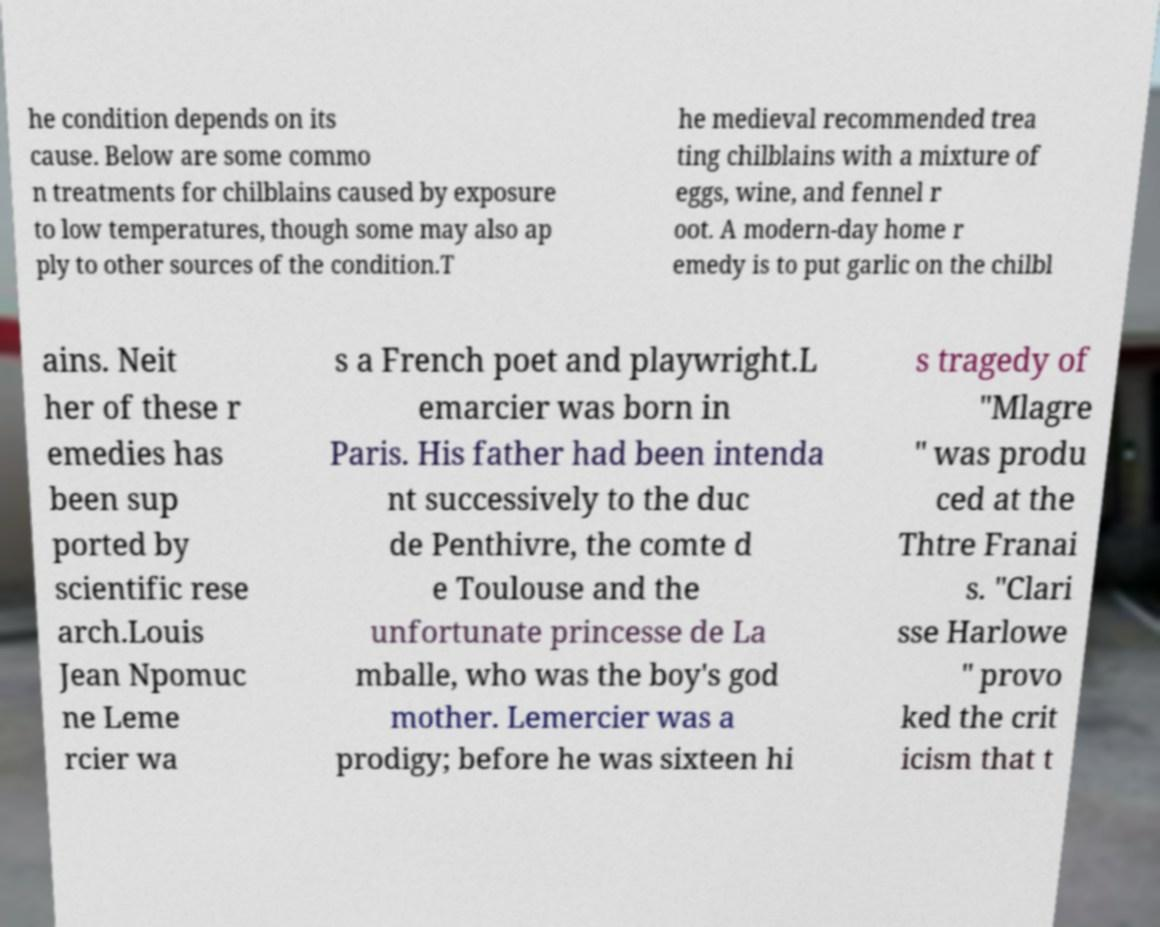Can you read and provide the text displayed in the image?This photo seems to have some interesting text. Can you extract and type it out for me? he condition depends on its cause. Below are some commo n treatments for chilblains caused by exposure to low temperatures, though some may also ap ply to other sources of the condition.T he medieval recommended trea ting chilblains with a mixture of eggs, wine, and fennel r oot. A modern-day home r emedy is to put garlic on the chilbl ains. Neit her of these r emedies has been sup ported by scientific rese arch.Louis Jean Npomuc ne Leme rcier wa s a French poet and playwright.L emarcier was born in Paris. His father had been intenda nt successively to the duc de Penthivre, the comte d e Toulouse and the unfortunate princesse de La mballe, who was the boy's god mother. Lemercier was a prodigy; before he was sixteen hi s tragedy of "Mlagre " was produ ced at the Thtre Franai s. "Clari sse Harlowe " provo ked the crit icism that t 